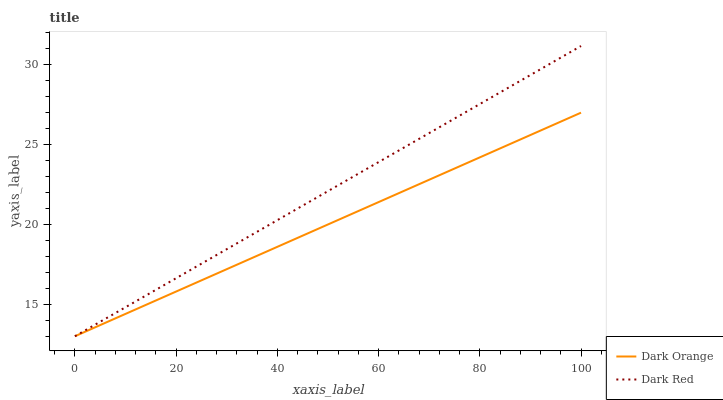Does Dark Orange have the minimum area under the curve?
Answer yes or no. Yes. Does Dark Red have the maximum area under the curve?
Answer yes or no. Yes. Does Dark Red have the minimum area under the curve?
Answer yes or no. No. Is Dark Orange the smoothest?
Answer yes or no. Yes. Is Dark Red the roughest?
Answer yes or no. Yes. Is Dark Red the smoothest?
Answer yes or no. No. Does Dark Red have the highest value?
Answer yes or no. Yes. Does Dark Orange intersect Dark Red?
Answer yes or no. Yes. Is Dark Orange less than Dark Red?
Answer yes or no. No. Is Dark Orange greater than Dark Red?
Answer yes or no. No. 